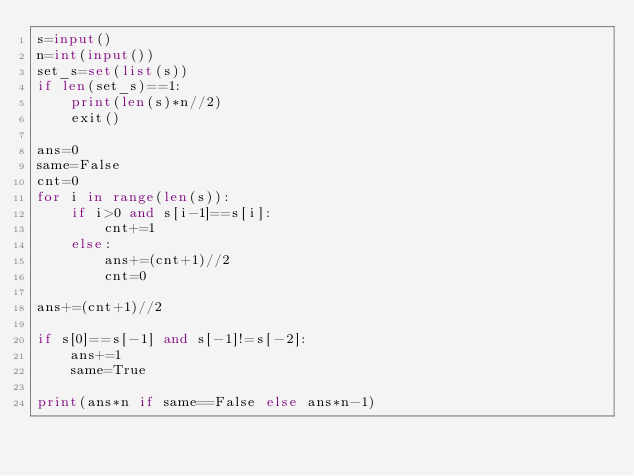Convert code to text. <code><loc_0><loc_0><loc_500><loc_500><_Python_>s=input()
n=int(input())
set_s=set(list(s))
if len(set_s)==1:
    print(len(s)*n//2)
    exit()

ans=0
same=False
cnt=0
for i in range(len(s)):
    if i>0 and s[i-1]==s[i]:
        cnt+=1
    else:
        ans+=(cnt+1)//2
        cnt=0

ans+=(cnt+1)//2

if s[0]==s[-1] and s[-1]!=s[-2]:
    ans+=1
    same=True

print(ans*n if same==False else ans*n-1)
</code> 